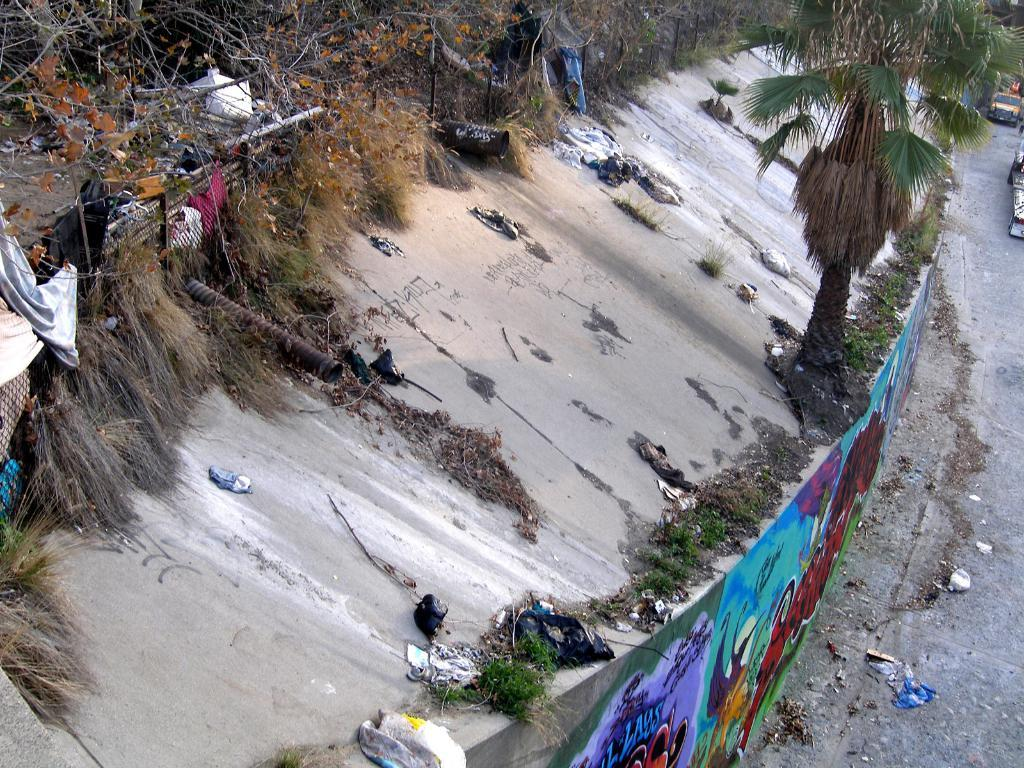What is hanging on the wall in the image? There is a painting on the wall in the image. What type of natural environment is visible in the image? There is grass and trees visible in the image. What type of objects can be seen in the image? Clothes and wooden objects are present in the image. What is happening on the road in the image? There are vehicles on the road in the image. Can you tell me how many tigers are present in the image? There are no tigers present in the image. What type of property is being feasted upon in the image? There is no feast or property present in the image. 